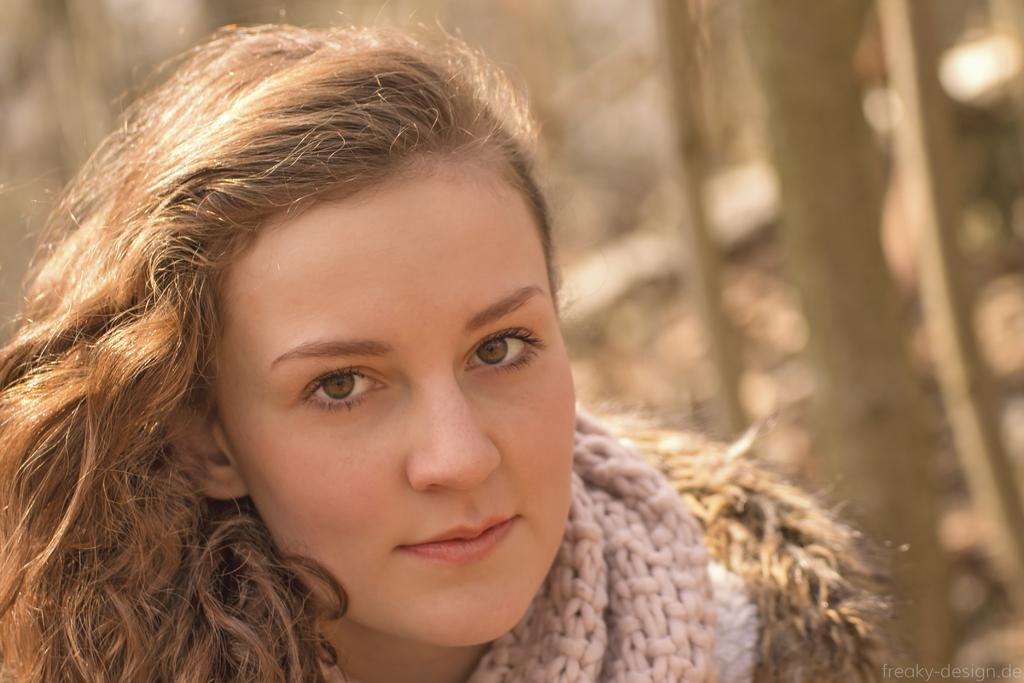Who is the main subject in the image? There is a woman in the image. What can be observed about the background of the image? The background of the image is blurred. What type of condition does the zipper have in the image? There is no zipper present in the image. How many steps can be seen in the image? There is no reference to steps in the image. 